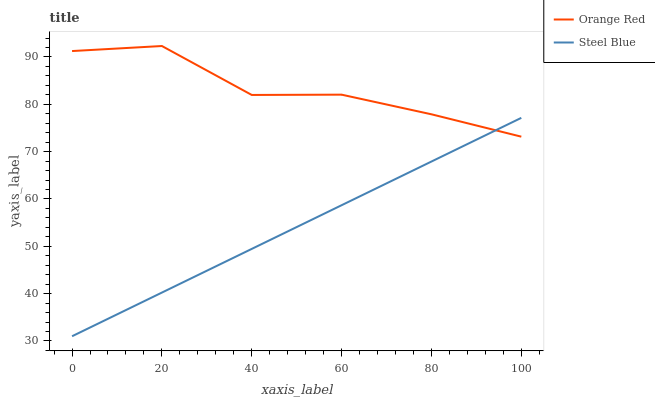Does Steel Blue have the maximum area under the curve?
Answer yes or no. No. Is Steel Blue the roughest?
Answer yes or no. No. Does Steel Blue have the highest value?
Answer yes or no. No. 